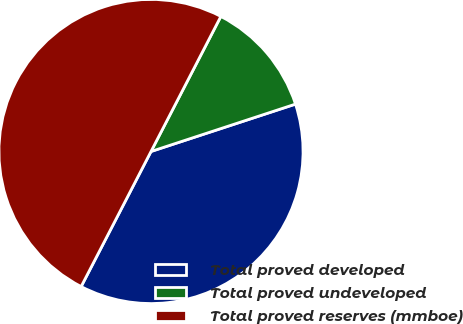Convert chart. <chart><loc_0><loc_0><loc_500><loc_500><pie_chart><fcel>Total proved developed<fcel>Total proved undeveloped<fcel>Total proved reserves (mmboe)<nl><fcel>37.64%<fcel>12.36%<fcel>50.0%<nl></chart> 